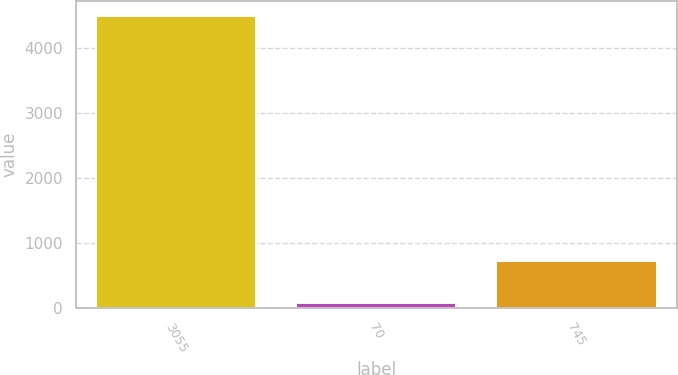Convert chart to OTSL. <chart><loc_0><loc_0><loc_500><loc_500><bar_chart><fcel>3055<fcel>70<fcel>745<nl><fcel>4500<fcel>77<fcel>721<nl></chart> 